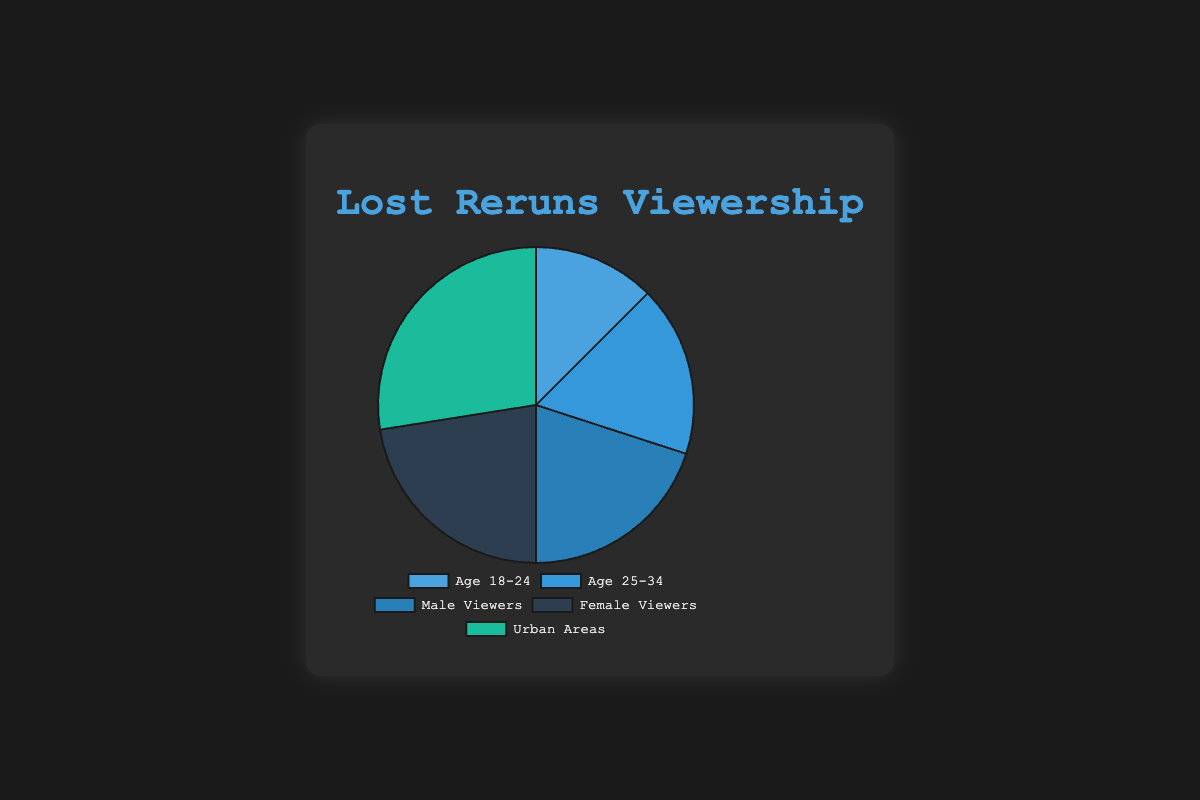Which age group has the highest viewership percentage? The chart shows that "Age 25-34" has the highest percentage among age groups with 35%.
Answer: Age 25-34 What is the total viewership percentage for Age 18-24 and Age 25-34 combined? Sum the percentages of "Age 18-24" (25%) and "Age 25-34" (35%). The total is 25 + 35 = 60%.
Answer: 60% Who has a higher percentage of viewership, male or female viewers? The chart indicates that "Female Viewers" have a higher percentage (45%) compared to "Male Viewers" (40%).
Answer: Female Viewers Between urban areas and Age 18-24, which category has a higher viewership by how much? "Urban Areas" have a viewership of 55% and "Age 18-24" has 25%. The difference is 55 - 25 = 30%.
Answer: Urban Areas by 30% What's the average viewership percentage of Age 18-24, Age 25-34, and Urban Areas? The sum of percentages for the three categories is 25% + 35% + 55% = 115%. The average is 115% / 3 = 38.33%.
Answer: 38.33% Which demographic category shows the highest viewership, and what color is it represented by? "Urban Areas" has the highest viewership at 55%, and it is represented by a green section in the chart.
Answer: Urban Areas, green Compare and rank the viewership percentages among Age 18-24, Age 25-34, and Male Viewers. Age 25-34 has the highest percentage (35%), followed by Male Viewers (40%) and Age 18-24 (25%).
Answer: Age 25-34 > Male Viewers > Age 18-24 What percentage of the viewership is not from urban areas? The viewership percentage from urban areas is 55%. The remaining percentage is 100% - 55% = 45%.
Answer: 45% Which category has the lowest viewership percentage and what is its value? The category "Age 18-24" has the lowest viewership percentage, which is 25%.
Answer: Age 18-24, 25% What is the combined viewership percentage of both male and female viewers? Sum the percentages of "Male Viewers" (40%) and "Female Viewers" (45%). The total is 40 + 45 = 85%.
Answer: 85% 